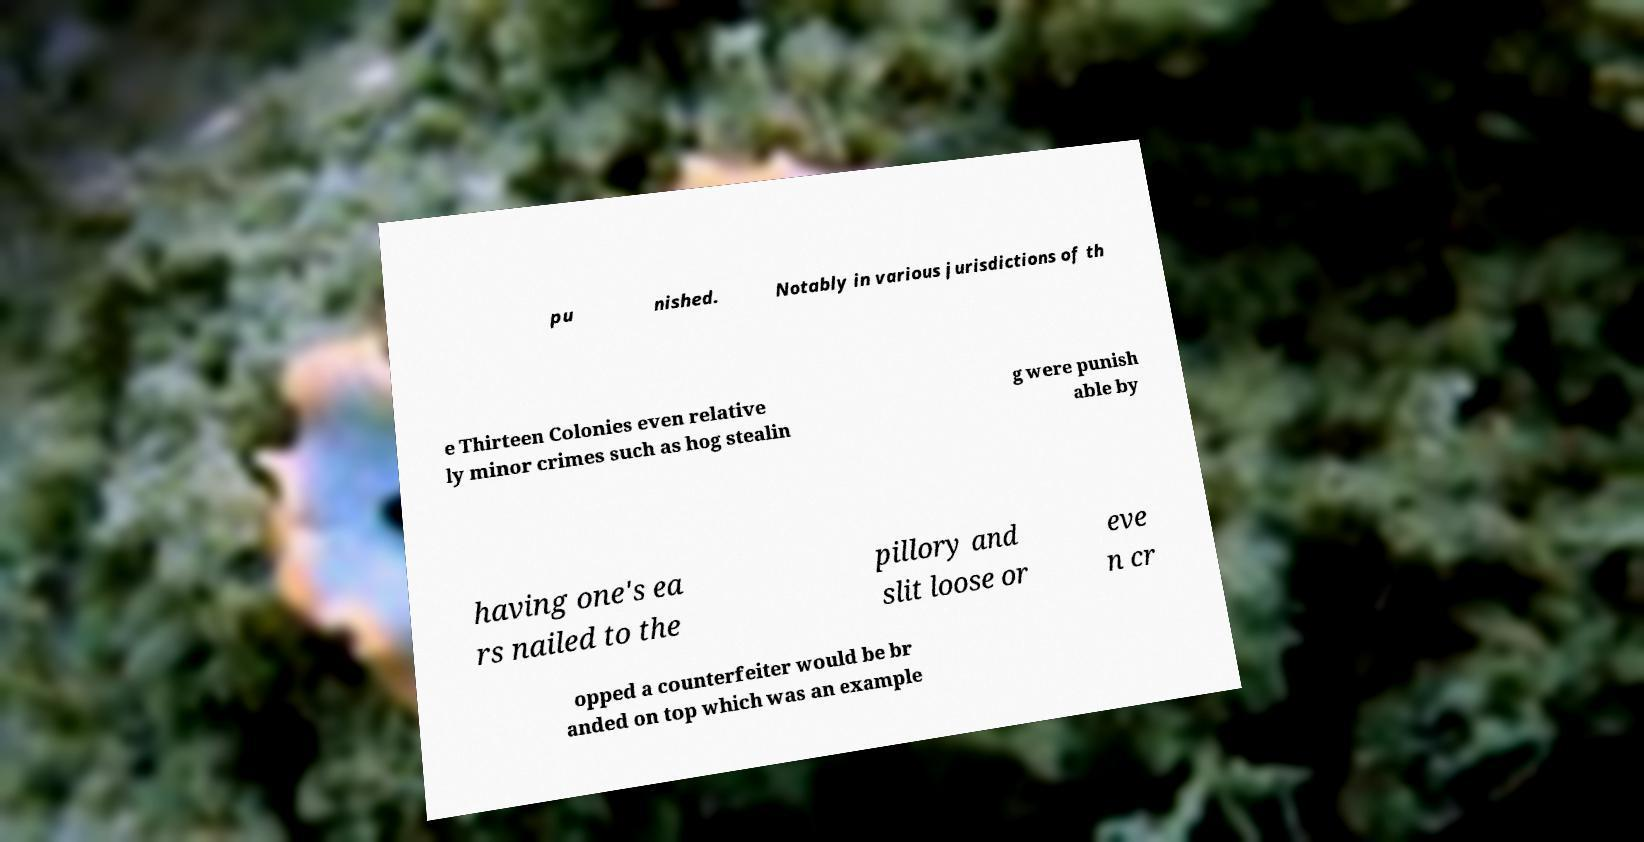For documentation purposes, I need the text within this image transcribed. Could you provide that? pu nished. Notably in various jurisdictions of th e Thirteen Colonies even relative ly minor crimes such as hog stealin g were punish able by having one's ea rs nailed to the pillory and slit loose or eve n cr opped a counterfeiter would be br anded on top which was an example 